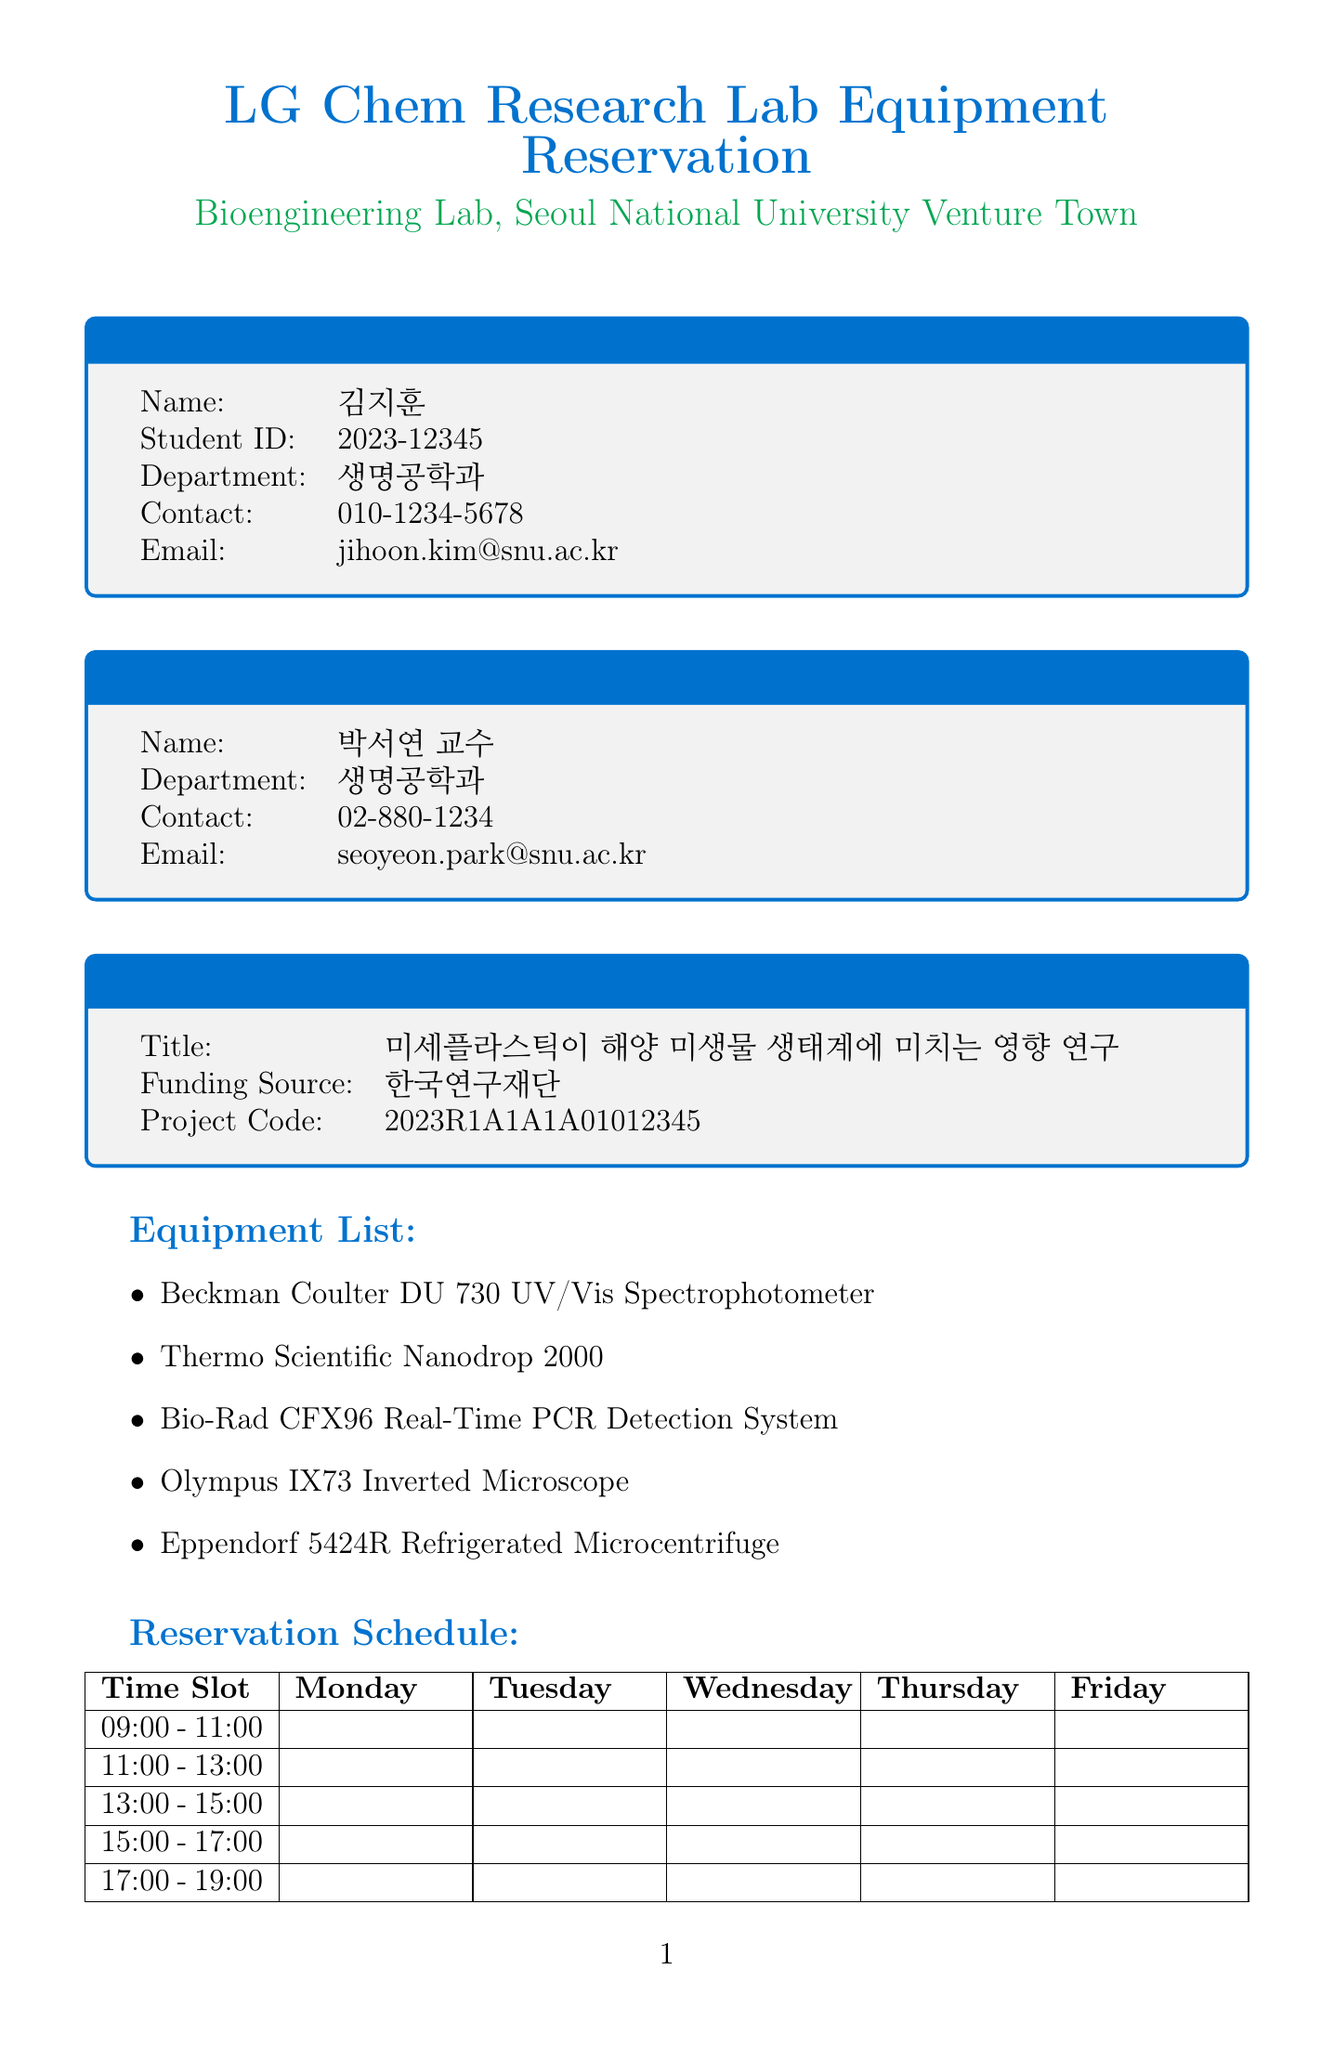What is the title of the project? The title of the project is listed under the Project Information section.
Answer: 미세플라스틱이 해양 미생물 생태계에 미치는 영향 연구 Who is the supervisor? The supervisor's name is stated in the Supervisor Information section.
Answer: 박서연 교수 What is the student ID of the researcher? The student ID can be found in the Researcher Information section.
Answer: 2023-12345 What is the contact number of the researcher? The contact number is provided in the Researcher Information section.
Answer: 010-1234-5678 List one equipment available for reservation. Several pieces of equipment are listed under the Equipment List section.
Answer: Beckman Coulter DU 730 UV/Vis Spectrophotometer What time slot is available on Friday? The available time slots are listed, and Friday contains several options.
Answer: 09:00 - 11:00 What is one of the safety requirements? The safety requirements are outlined in a specific section of the document.
Answer: 실험실 안전교육 이수 필수 What is the funding source for the project? The funding source for the project is stated in the Project Information section.
Answer: 한국연구재단 How long in advance must a reservation be canceled? The reservation cancellation policy is mentioned in the Additional Notes section.
Answer: 24시간 